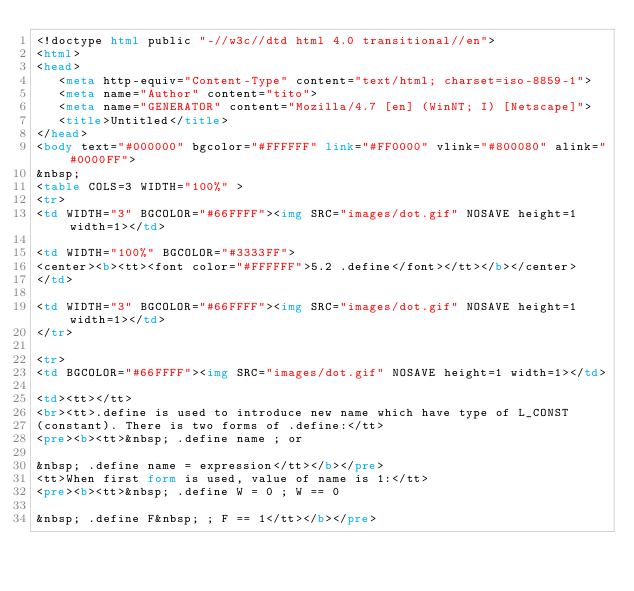<code> <loc_0><loc_0><loc_500><loc_500><_HTML_><!doctype html public "-//w3c//dtd html 4.0 transitional//en">
<html>
<head>
   <meta http-equiv="Content-Type" content="text/html; charset=iso-8859-1">
   <meta name="Author" content="tito">
   <meta name="GENERATOR" content="Mozilla/4.7 [en] (WinNT; I) [Netscape]">
   <title>Untitled</title>
</head>
<body text="#000000" bgcolor="#FFFFFF" link="#FF0000" vlink="#800080" alink="#0000FF">
&nbsp;
<table COLS=3 WIDTH="100%" >
<tr>
<td WIDTH="3" BGCOLOR="#66FFFF"><img SRC="images/dot.gif" NOSAVE height=1 width=1></td>

<td WIDTH="100%" BGCOLOR="#3333FF">
<center><b><tt><font color="#FFFFFF">5.2 .define</font></tt></b></center>
</td>

<td WIDTH="3" BGCOLOR="#66FFFF"><img SRC="images/dot.gif" NOSAVE height=1 width=1></td>
</tr>

<tr>
<td BGCOLOR="#66FFFF"><img SRC="images/dot.gif" NOSAVE height=1 width=1></td>

<td><tt></tt>
<br><tt>.define is used to introduce new name which have type of L_CONST
(constant). There is two forms of .define:</tt>
<pre><b><tt>&nbsp; .define name ; or

&nbsp; .define name = expression</tt></b></pre>
<tt>When first form is used, value of name is 1:</tt>
<pre><b><tt>&nbsp; .define W = 0 ; W == 0

&nbsp; .define F&nbsp; ; F == 1</tt></b></pre></code> 